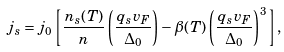Convert formula to latex. <formula><loc_0><loc_0><loc_500><loc_500>j _ { s } = j _ { 0 } \left [ \frac { n _ { s } ( T ) } { n } \left ( \frac { q _ { s } v _ { F } } { \Delta _ { 0 } } \right ) - \beta ( T ) \left ( \frac { q _ { s } v _ { F } } { \Delta _ { 0 } } \right ) ^ { 3 } \right ] ,</formula> 